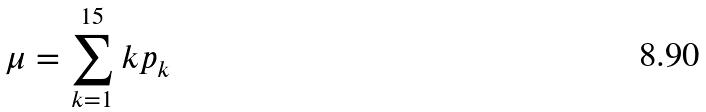Convert formula to latex. <formula><loc_0><loc_0><loc_500><loc_500>\mu = \sum _ { k = 1 } ^ { 1 5 } k p _ { k }</formula> 